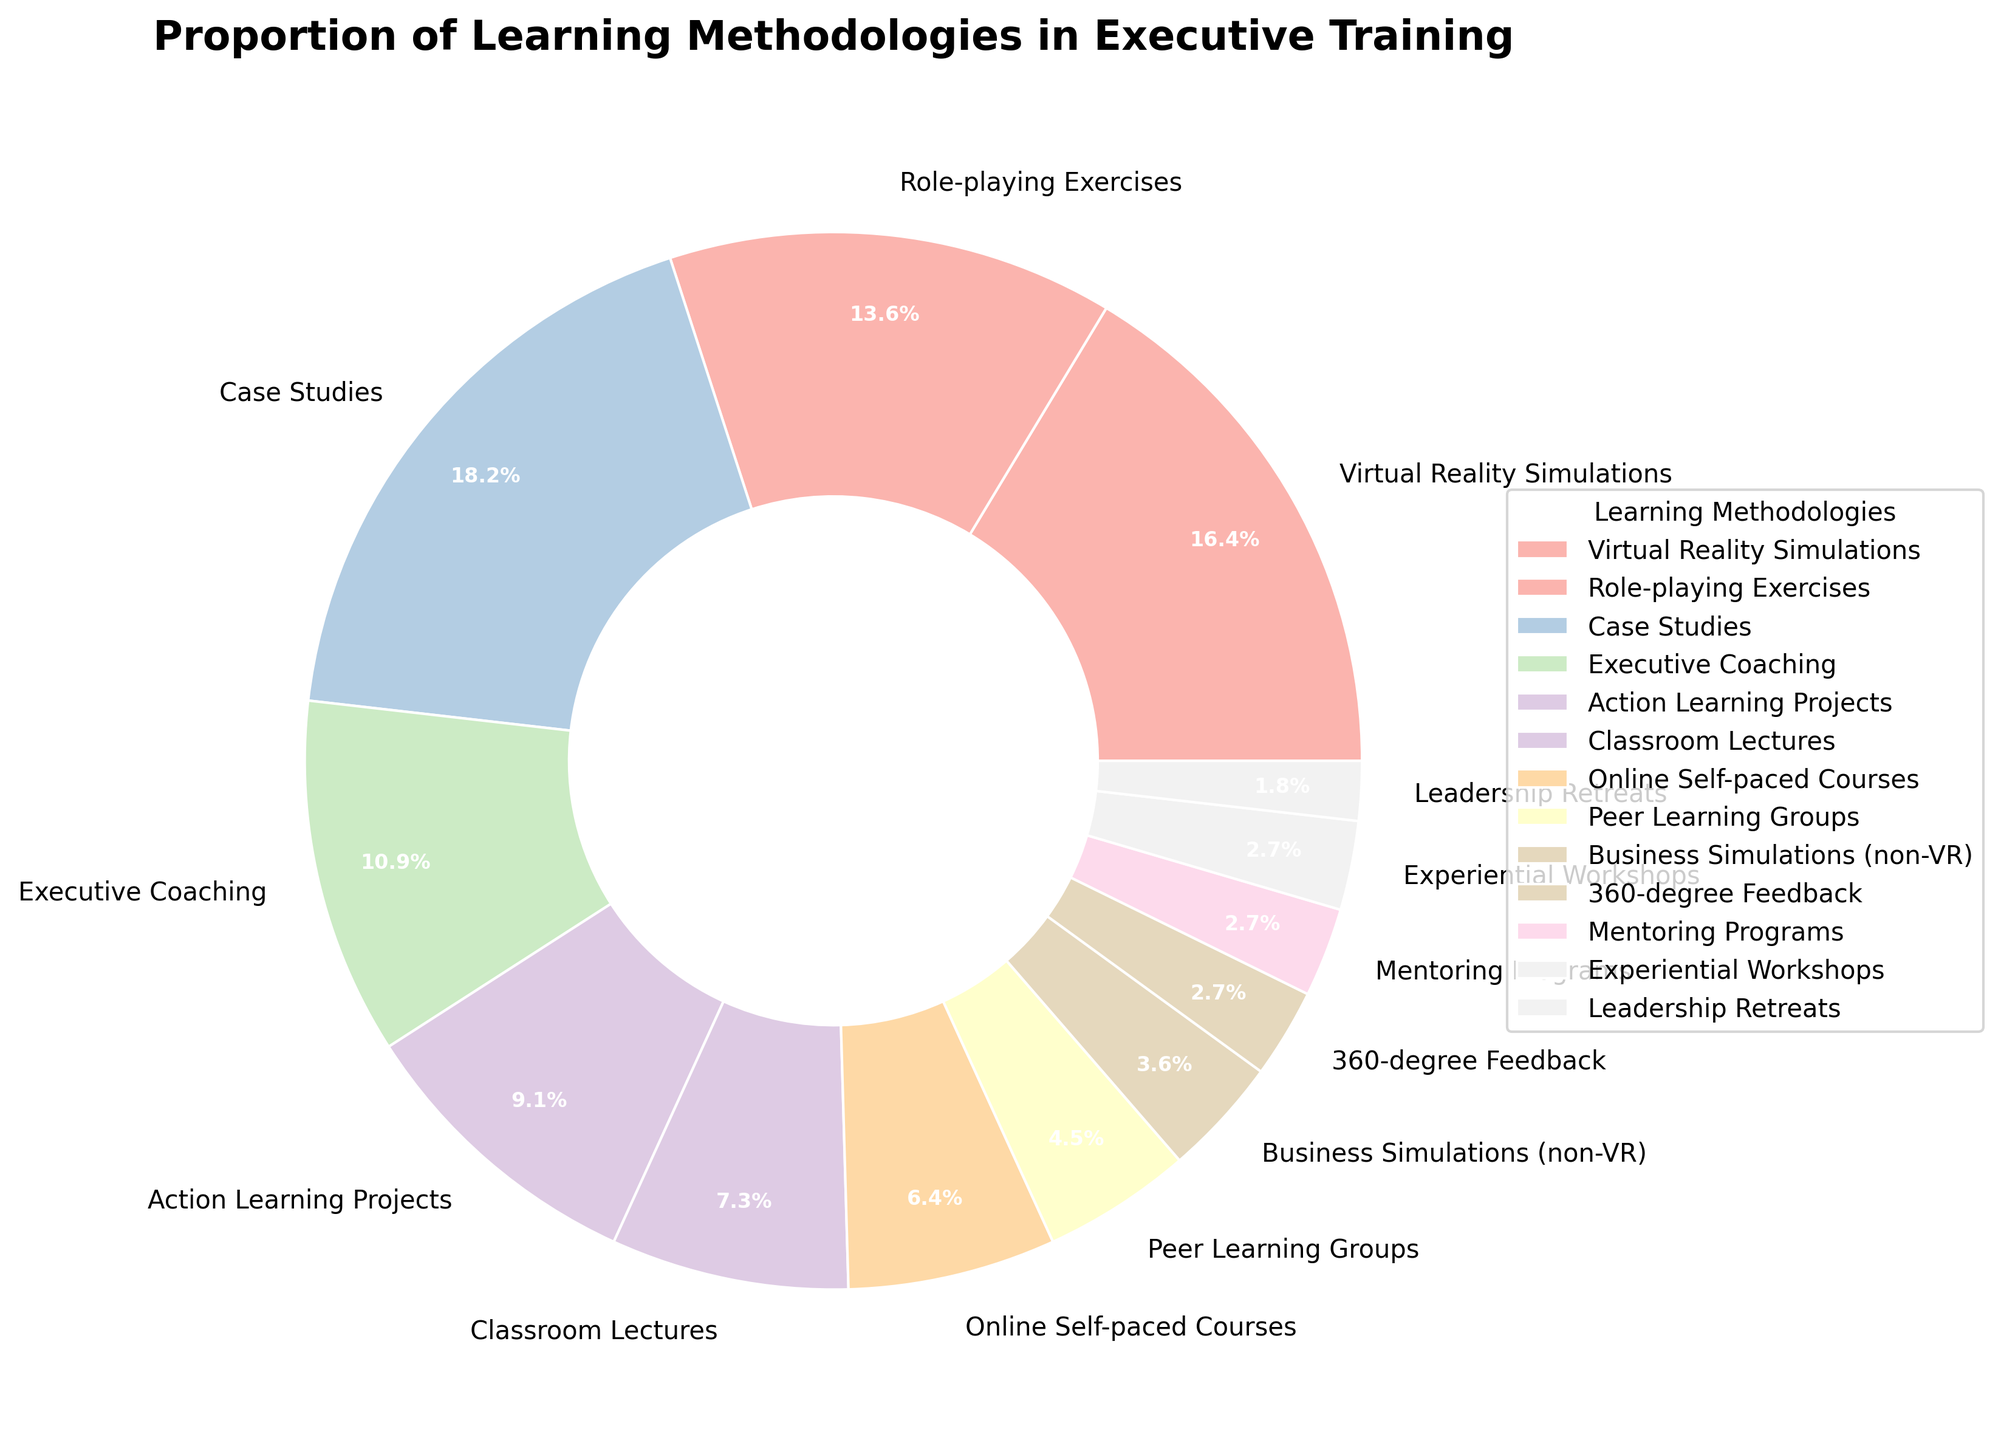What is the largest learning methodology category in the chart? The largest learning methodology category is identified by finding the segment with the highest percentage. On the pie chart, the segment labeled "Case Studies" with 20% is the largest.
Answer: Case Studies (20%) Which learning methodologies combined make up exactly half of the total percentage? To find the methodologies that make up 50% combined, sum the percentages starting from the largest until the total reaches or exceeds 50%. "Case Studies" (20%), "Virtual Reality Simulations" (18%), and "Role-playing Exercises" (15%) together make up 53%, hence the closest combination to 50%.
Answer: Case Studies, Virtual Reality Simulations, Role-playing Exercises Which learning methodology has the smallest share in the chart? The smallest share is held by the categories with the lowest percentage values. On the chart, "Leadership Retreats" is noted as having the smallest share with 2%.
Answer: Leadership Retreats (2%) Compare the combined percentage of methodologies using some form of simulations (both VR and non-VR) with the combined percentage of methodologies using feedback mechanisms. First, sum the percentages of methodologies involving simulations: "Virtual Reality Simulations" (18%) and "Business Simulations (non-VR)" (4%) total to 22%. Then, sum those involving feedback mechanisms: "360-degree Feedback" (3%). Simulations (22%) exceed feedback mechanisms (3%).
Answer: Simulations (22%) > Feedback mechanisms (3%) What percentage of the total methodologies is formed by non-experiential methods like Classroom Lectures and Online Self-paced Courses? Sum the percentages of "Classroom Lectures" (8%) and "Online Self-paced Courses" (7%) to determine the total percentage of non-experiential methods. 8% + 7% = 15%.
Answer: 15% Which learning methodology categories together total to less than 10%? Sum the percentages of the smallest categories until the total is less than 10%. "Leadership Retreats" (2%), "Mentoring Programs" (3%), "Experiential Workshops" (3%), and "360-degree Feedback" (3%) sum to 11%, which is just above 10%, thus "Business Simulations (non-VR)" with 4% alone fits the criteria. Adjust this to the next possible set fitting the criteria if needed.
Answer: Business Simulations (non-VR) alone best fits below 10% How do peer learning groups compare percentage-wise to executive coaching? Compare the percentages of "Peer Learning Groups" (5%) and "Executive Coaching" (12%). Executive Coaching has a higher percentage.
Answer: Peer Learning Groups (5%) < Executive Coaching (12%) Which visual attributes (like color and size) help in distinguishing between "Case Studies" and "Classroom Lectures"? The pie chart uses both the size of the segments (with "Case Studies" being larger) and distinctive colors from the applied colormap to differentiate between segments. "Case Studies" with a larger segment and one color, while "Classroom Lectures" has a smaller segment and another differentiating color.
Answer: Size and color What are the cumulative percentages of methodologies that fall in the range between 10% to 20%? Identify methodologies with percentages in the range of 10% to 20%: "Virtual Reality Simulations" (18%), "Role-playing Exercises" (15%), "Executive Coaching" (12%), "Action Learning Projects" (10%). Adding these up: 18% + 15% + 12% + 10% = 55%.
Answer: 55% What is the difference in percentages between "Action Learning Projects" and "Role-playing Exercises"? Subtract the percentage of "Role-playing Exercises" (15%) from "Action Learning Projects" (10%). 15% - 10% = 5%.
Answer: 5% 